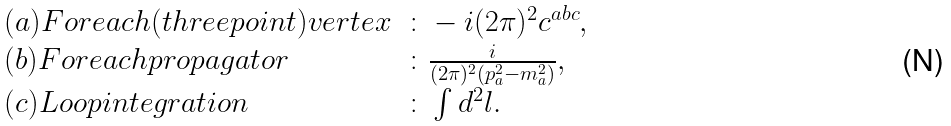<formula> <loc_0><loc_0><loc_500><loc_500>\begin{array} { l l } ( a ) F o r e a c h ( t h r e e p o i n t ) v e r t e x & \colon - i ( 2 \pi ) ^ { 2 } c ^ { a b c } , \\ ( b ) F o r e a c h p r o p a g a t o r & \colon \frac { i } { ( 2 \pi ) ^ { 2 } ( p _ { a } ^ { 2 } - m _ { a } ^ { 2 } ) } , \\ ( c ) L o o p i n t e g r a t i o n & \colon \int d ^ { 2 } l . \end{array}</formula> 